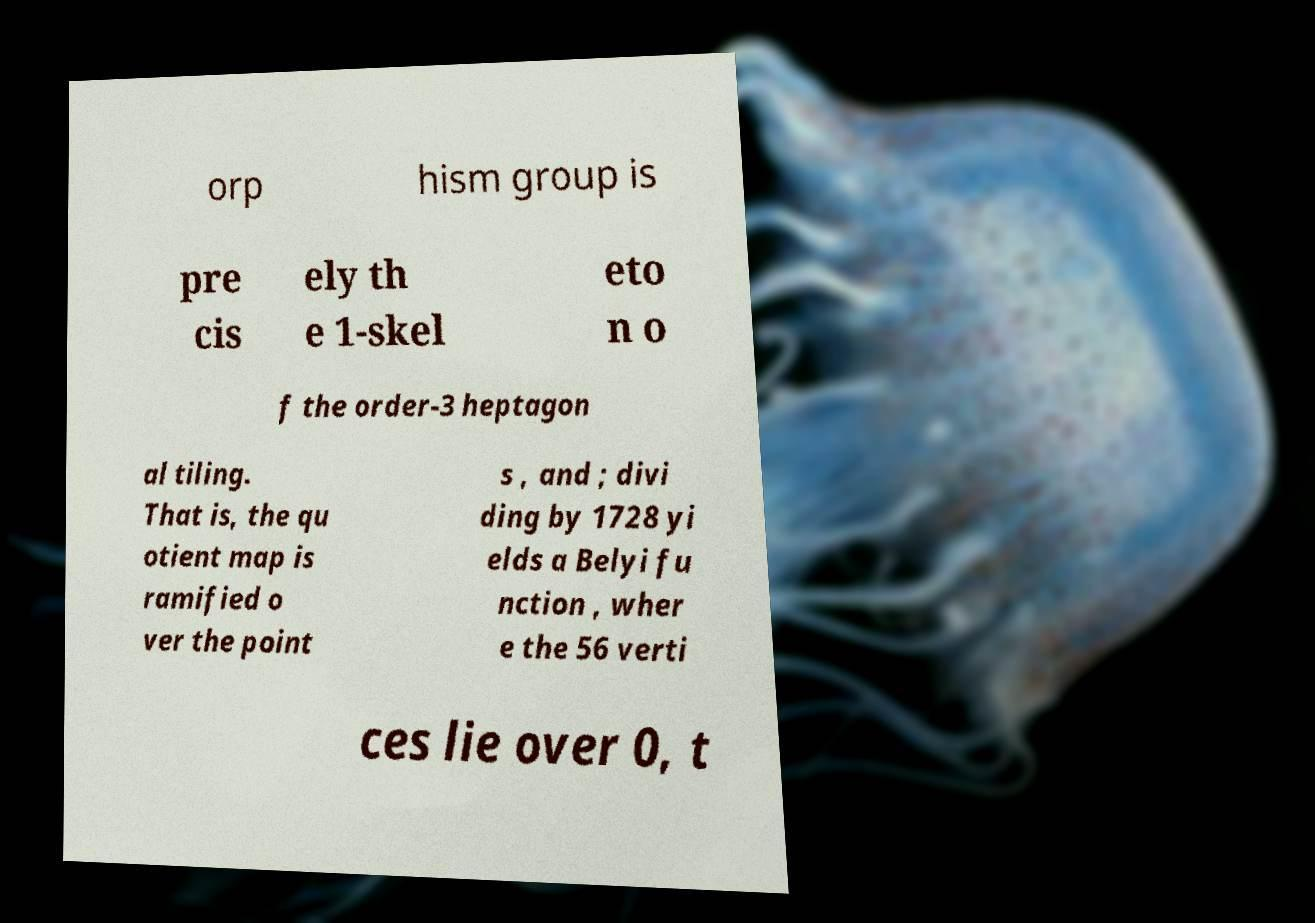For documentation purposes, I need the text within this image transcribed. Could you provide that? orp hism group is pre cis ely th e 1-skel eto n o f the order-3 heptagon al tiling. That is, the qu otient map is ramified o ver the point s , and ; divi ding by 1728 yi elds a Belyi fu nction , wher e the 56 verti ces lie over 0, t 